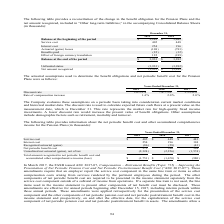According to Sykes Enterprises Incorporated's financial document, What was the Service cost in 2019? According to the financial document, $405 (in thousands). The relevant text states: "Service cost 405 448..." Also, What was the interest cost in 2018? According to the financial document, 196 (in thousands). The relevant text states: "Interest cost 254 196 194..." Also, In which years is the information about the net periodic benefit cost and other accumulated comprehensive income for the Pension Plans provided? The document contains multiple relevant values: 2019, 2018, 2017. From the document: "2019 2018 2017 2019 2018 2017 2019 2018 2017..." Additionally, In which year was Net periodic benefit cost the largest? According to the financial document, 2017. The relevant text states: "2019 2018 2017..." Also, can you calculate: What was the change in interest cost in 2019 from 2018? Based on the calculation: 254-196, the result is 58 (in thousands). This is based on the information: "Interest cost 254 196 194 Interest cost 254 196 194..." The key data points involved are: 196, 254. Also, can you calculate: What was the percentage change in interest cost in 2019 from 2018? To answer this question, I need to perform calculations using the financial data. The calculation is: (254-196)/196, which equals 29.59 (percentage). This is based on the information: "Interest cost 254 196 194 Interest cost 254 196 194..." The key data points involved are: 196, 254. 